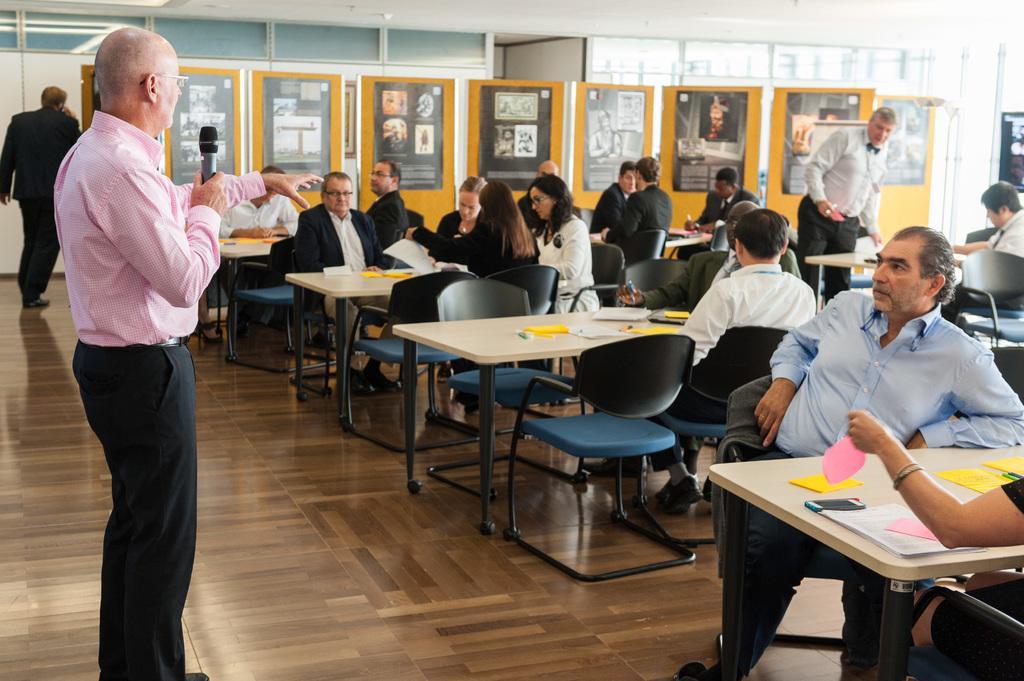Could you give a brief overview of what you see in this image? In this image there is man holding a mike and talking to the people. And there are chairs and tables,Some papers are place on the table and people are working. There is a man walking away from the place. There are yellow colored sheets with some papers attached to it. There is a man standing and moving from his place. 